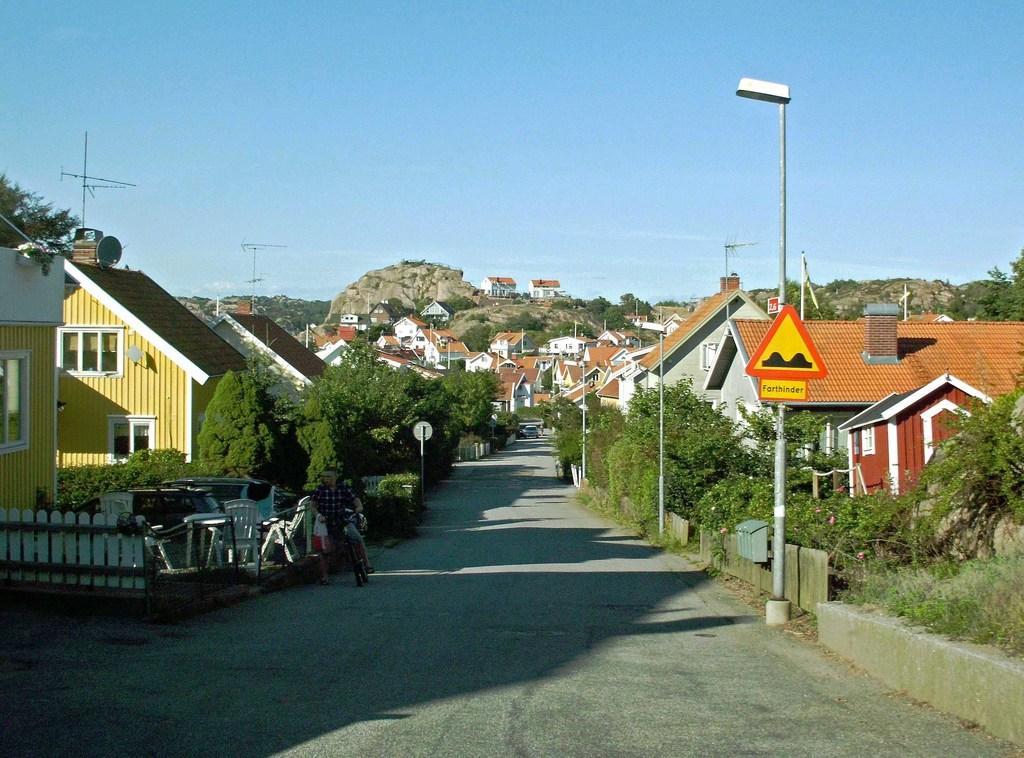Can you describe this image briefly? This is an outside view. At the bottom there is a road. On both sides of the road there are many trees and buildings and also poles. On the left side there is a fencing and I can see few chairs and table in the garden. There is a person riding the bicycle on the road. In the background there are some rocks. At the top of the image I can see the sky. 